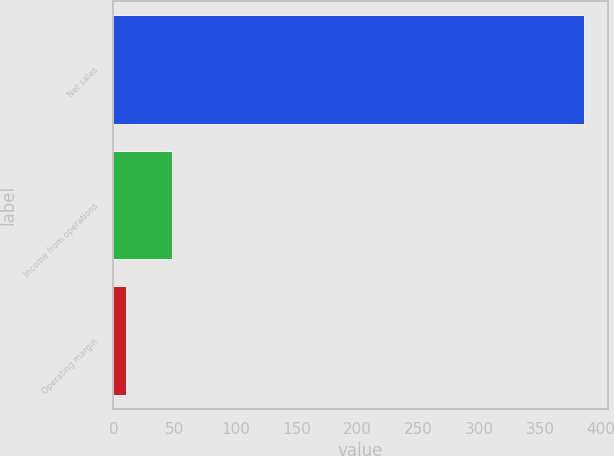Convert chart to OTSL. <chart><loc_0><loc_0><loc_500><loc_500><bar_chart><fcel>Net sales<fcel>Income from operations<fcel>Operating margin<nl><fcel>386<fcel>47.69<fcel>10.1<nl></chart> 